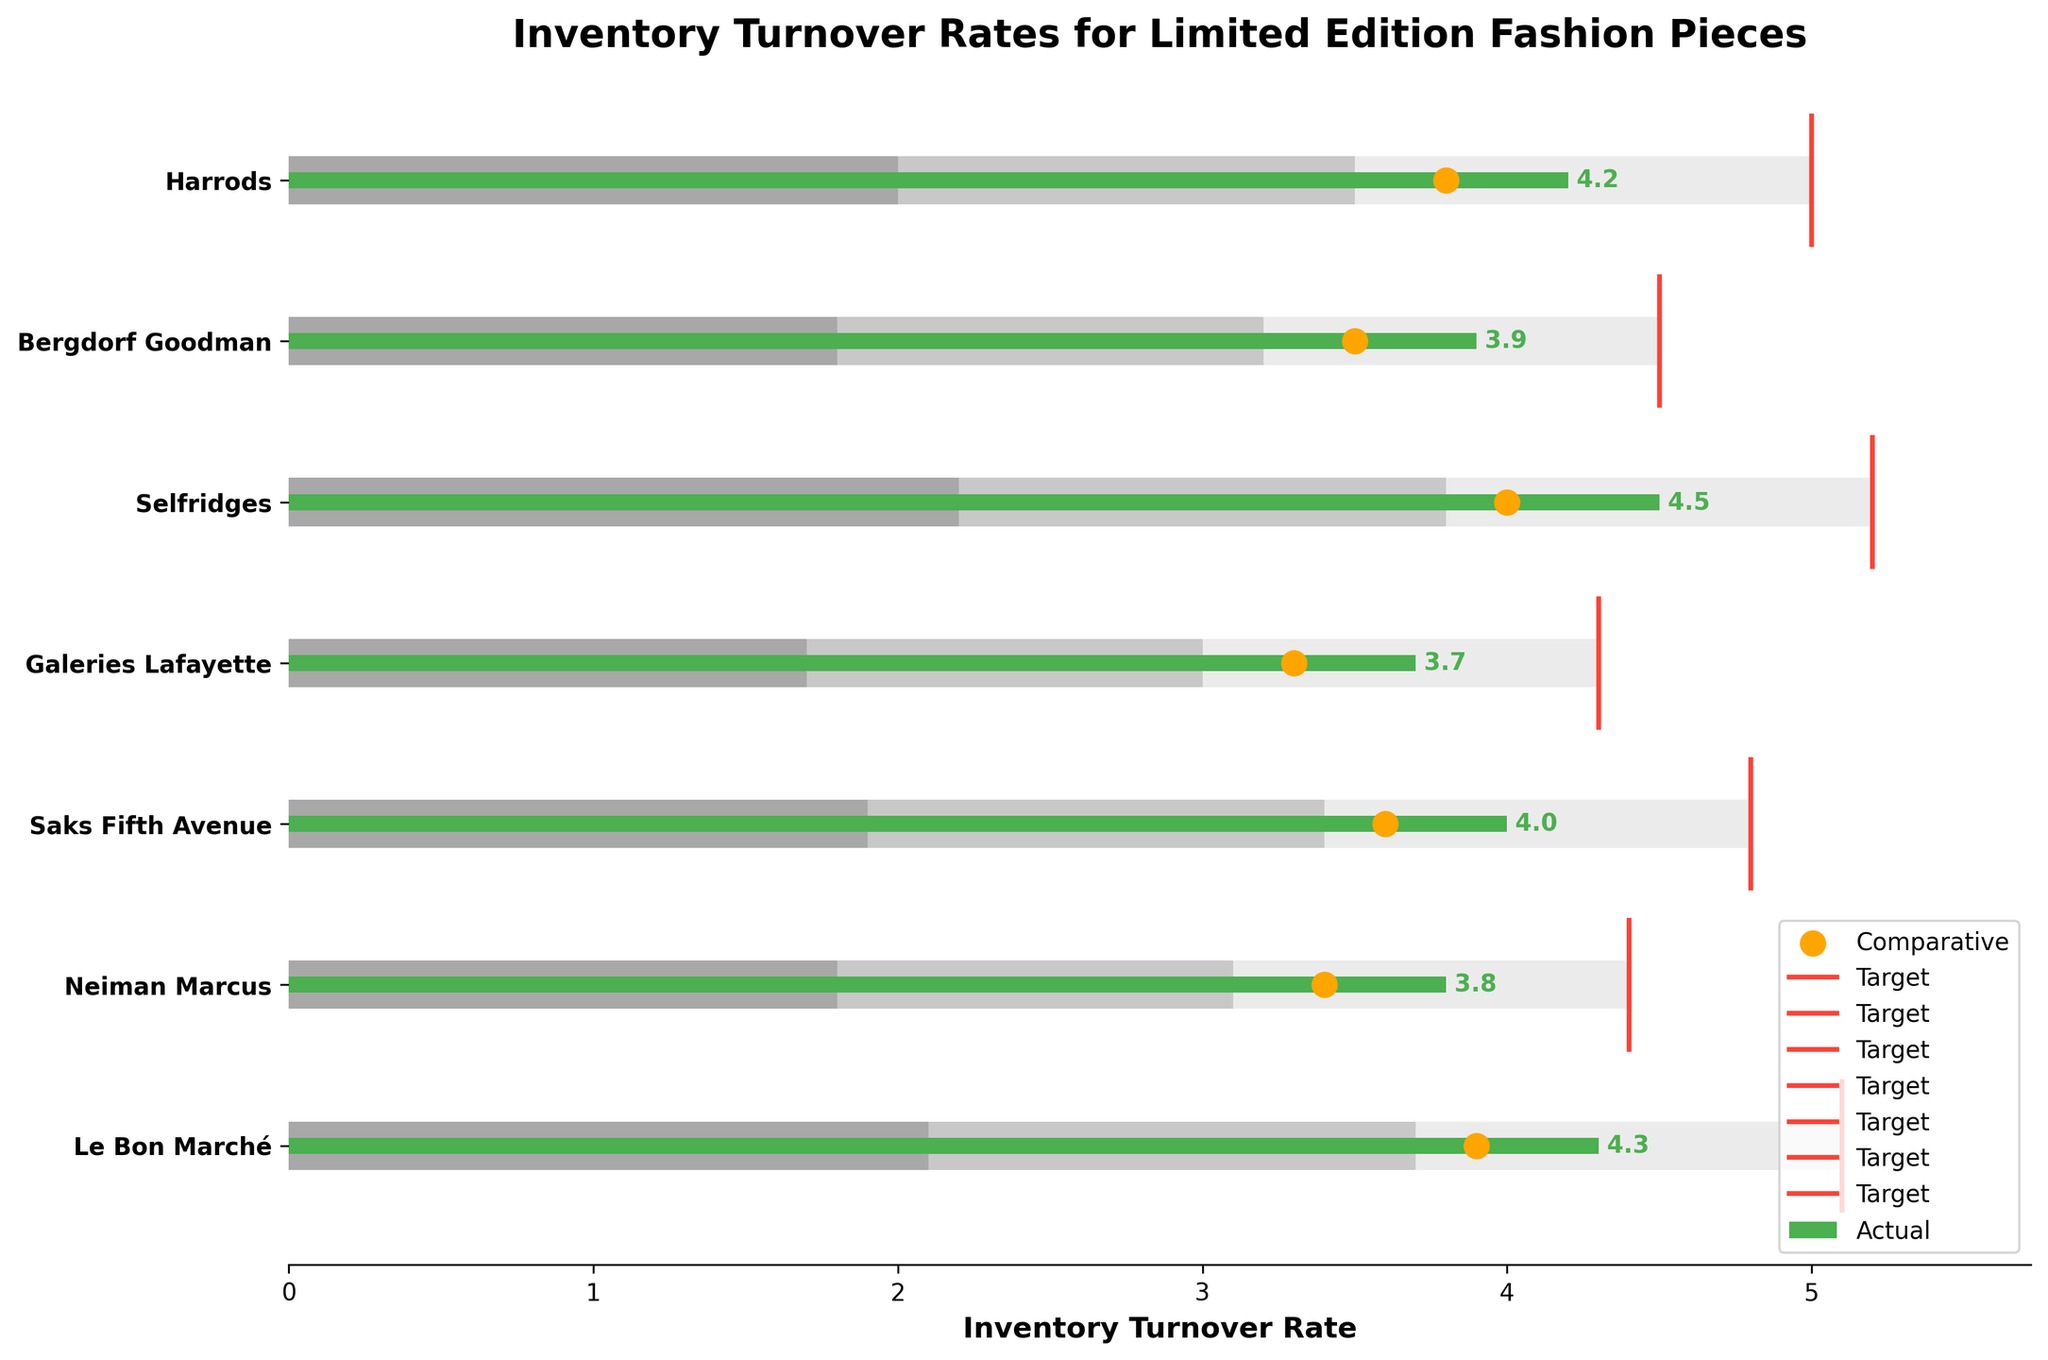What's the title of the chart? The title of the chart is displayed at the top of the figure.
Answer: Inventory Turnover Rates for Limited Edition Fashion Pieces What are the axes labels on the chart? The x-axis label is at the bottom, "Inventory Turnover Rate," and the y-axis label is not explicitly mentioned; it represents the stores.
Answer: x-axis: Inventory Turnover Rate, y-axis: Stores Which store has the highest actual inventory turnover rate? By observing the green bars representing the actual inventory turnover rates, identify the longest bar.
Answer: Selfridges What's the actual inventory turnover rate for Bergdorf Goodman compared to its target? Refer to the green bar for the actual inventory turnover rate and the red line for the target. The actual rate is 3.9 and the target is 4.5.
Answer: Actual: 3.9, Target: 4.5 How many stores have actual turnover rates that do not meet their targets? Compare the green bars (actual rates) with the red lines (target rates) for each store. Count how many green bars are shorter than their respective red lines.
Answer: 6 Which store's actual rate is closest to its target? Compare the lengths of green bars and the proximity to their respective red lines. Identify the smallest difference.
Answer: Saks Fifth Avenue What are the comparative turnover rates shown in the chart? Identify the orange dots representing the comparative turnover rates for each store. They are: 3.8, 3.5, 4.0, 3.3, 3.6, 3.4, and 3.9.
Answer: 3.8, 3.5, 4.0, 3.3, 3.6, 3.4, 3.9 Which stores exceed their comparative turnover rates? Compare the green bars (actual rates) to the positions of the orange dots (comparative rates), and count how many green bars are taller.
Answer: Harrods, Selfridges, Le Bon Marché What's the average target inventory turnover rate across all stores? Sum up all target values and divide by the number of stores: (5.0 + 4.5 + 5.2 + 4.3 + 4.8 + 4.4 + 5.1) / 7.
Answer: 4.76 Which store has the smallest difference between its actual and comparative turnover rates? Calculate the difference between the green bar and the orange dot for each store. Identify the smallest difference.
Answer: Neiman Marcus Is any store's actual turnover rate within its first range? Compare the green bars (actual rates) with the gray bars for the first range. Check if any green bar falls within its first range (Range1).
Answer: No 